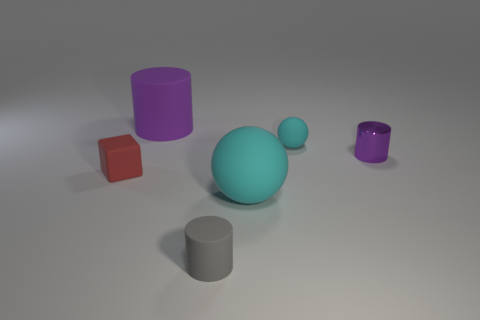What size is the object that is the same color as the tiny metallic cylinder?
Offer a terse response. Large. There is a large object that is in front of the small cyan matte sphere; what material is it?
Give a very brief answer. Rubber. What number of other objects are there of the same shape as the small red rubber thing?
Ensure brevity in your answer.  0. Does the red matte thing have the same shape as the tiny purple object?
Provide a short and direct response. No. Are there any rubber things on the right side of the tiny red rubber cube?
Your response must be concise. Yes. How many objects are tiny purple shiny objects or tiny blue matte spheres?
Keep it short and to the point. 1. How many other things are there of the same size as the purple matte thing?
Provide a short and direct response. 1. What number of small objects are both behind the tiny red object and in front of the tiny cyan matte ball?
Offer a very short reply. 1. Do the matte cylinder in front of the large purple thing and the cyan thing in front of the metal object have the same size?
Offer a terse response. No. There is a matte ball that is in front of the small block; what size is it?
Offer a very short reply. Large. 